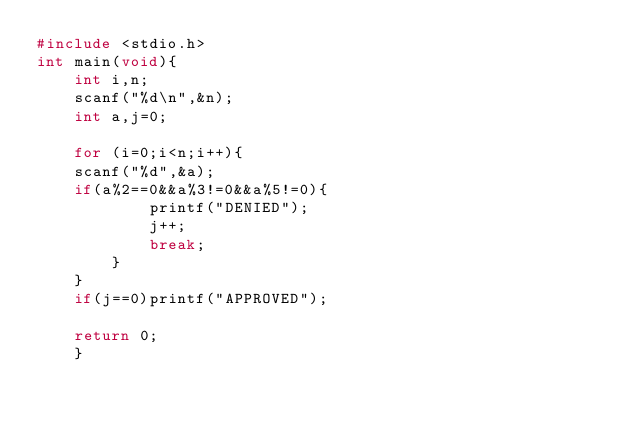<code> <loc_0><loc_0><loc_500><loc_500><_C_>#include <stdio.h>
int main(void){
    int i,n;
    scanf("%d\n",&n);
    int a,j=0;
    
    for (i=0;i<n;i++){
	scanf("%d",&a);
	if(a%2==0&&a%3!=0&&a%5!=0){
	        printf("DENIED");
	        j++;
	        break;
	    }
	}
    if(j==0)printf("APPROVED");
 
    return 0;
    }</code> 